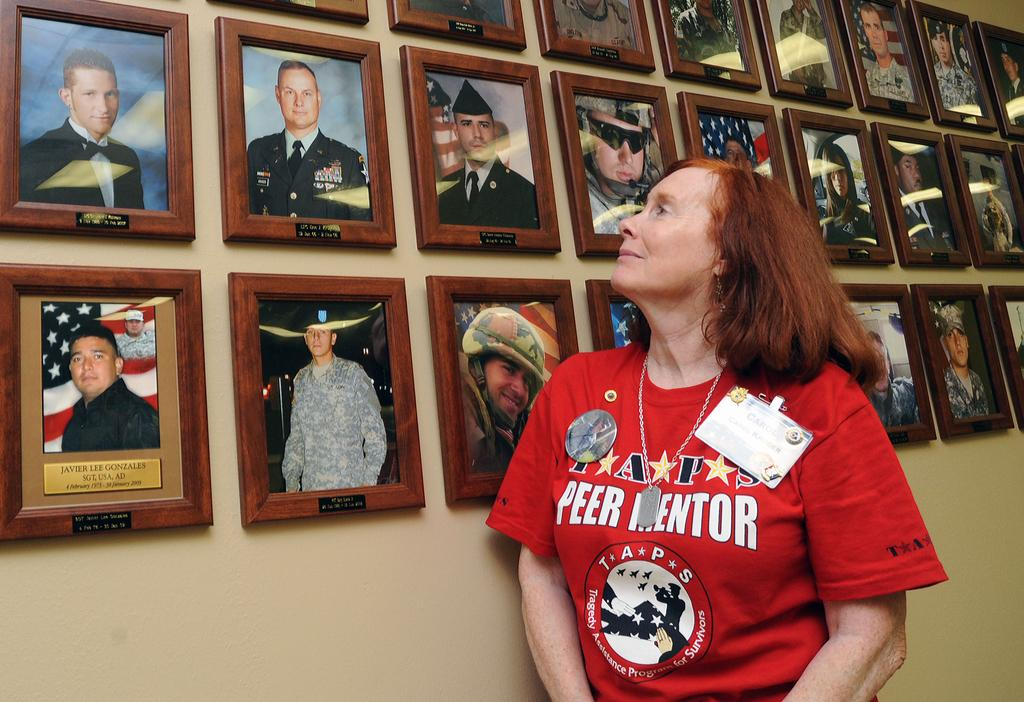What is the main subject of the image? There is a person standing in the image. Where is the person standing in relation to the wall? The person is standing near a wall. What can be seen attached to the wall? There are photo frames attached to the wall. What type of plants are being used as decorations for the feast in the image? There is no feast or plants present in the image; it features a person standing near a wall with photo frames attached to it. 